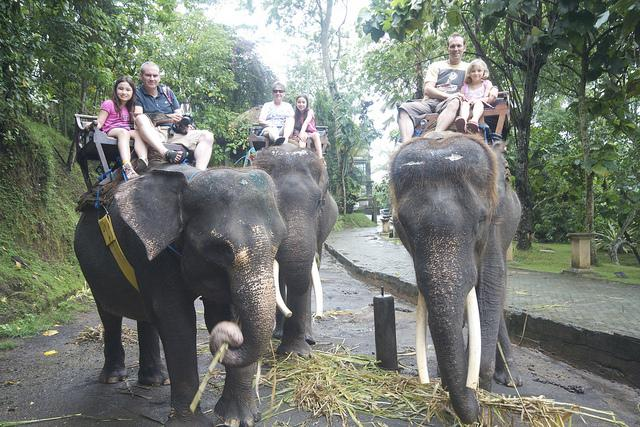What is hoisted atop the elephants to help the people ride them? seats 